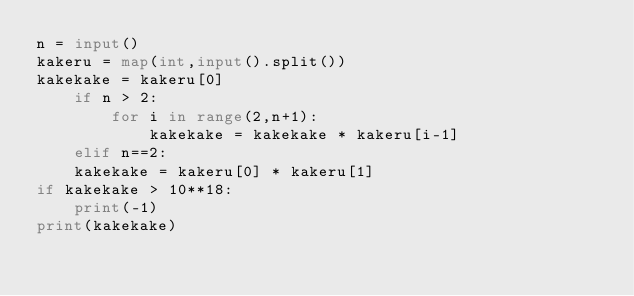<code> <loc_0><loc_0><loc_500><loc_500><_Python_>n = input()
kakeru = map(int,input().split())
kakekake = kakeru[0]
    if n > 2:
        for i in range(2,n+1):
            kakekake = kakekake * kakeru[i-1]
    elif n==2:
    kakekake = kakeru[0] * kakeru[1]
if kakekake > 10**18:
    print(-1)
print(kakekake)</code> 